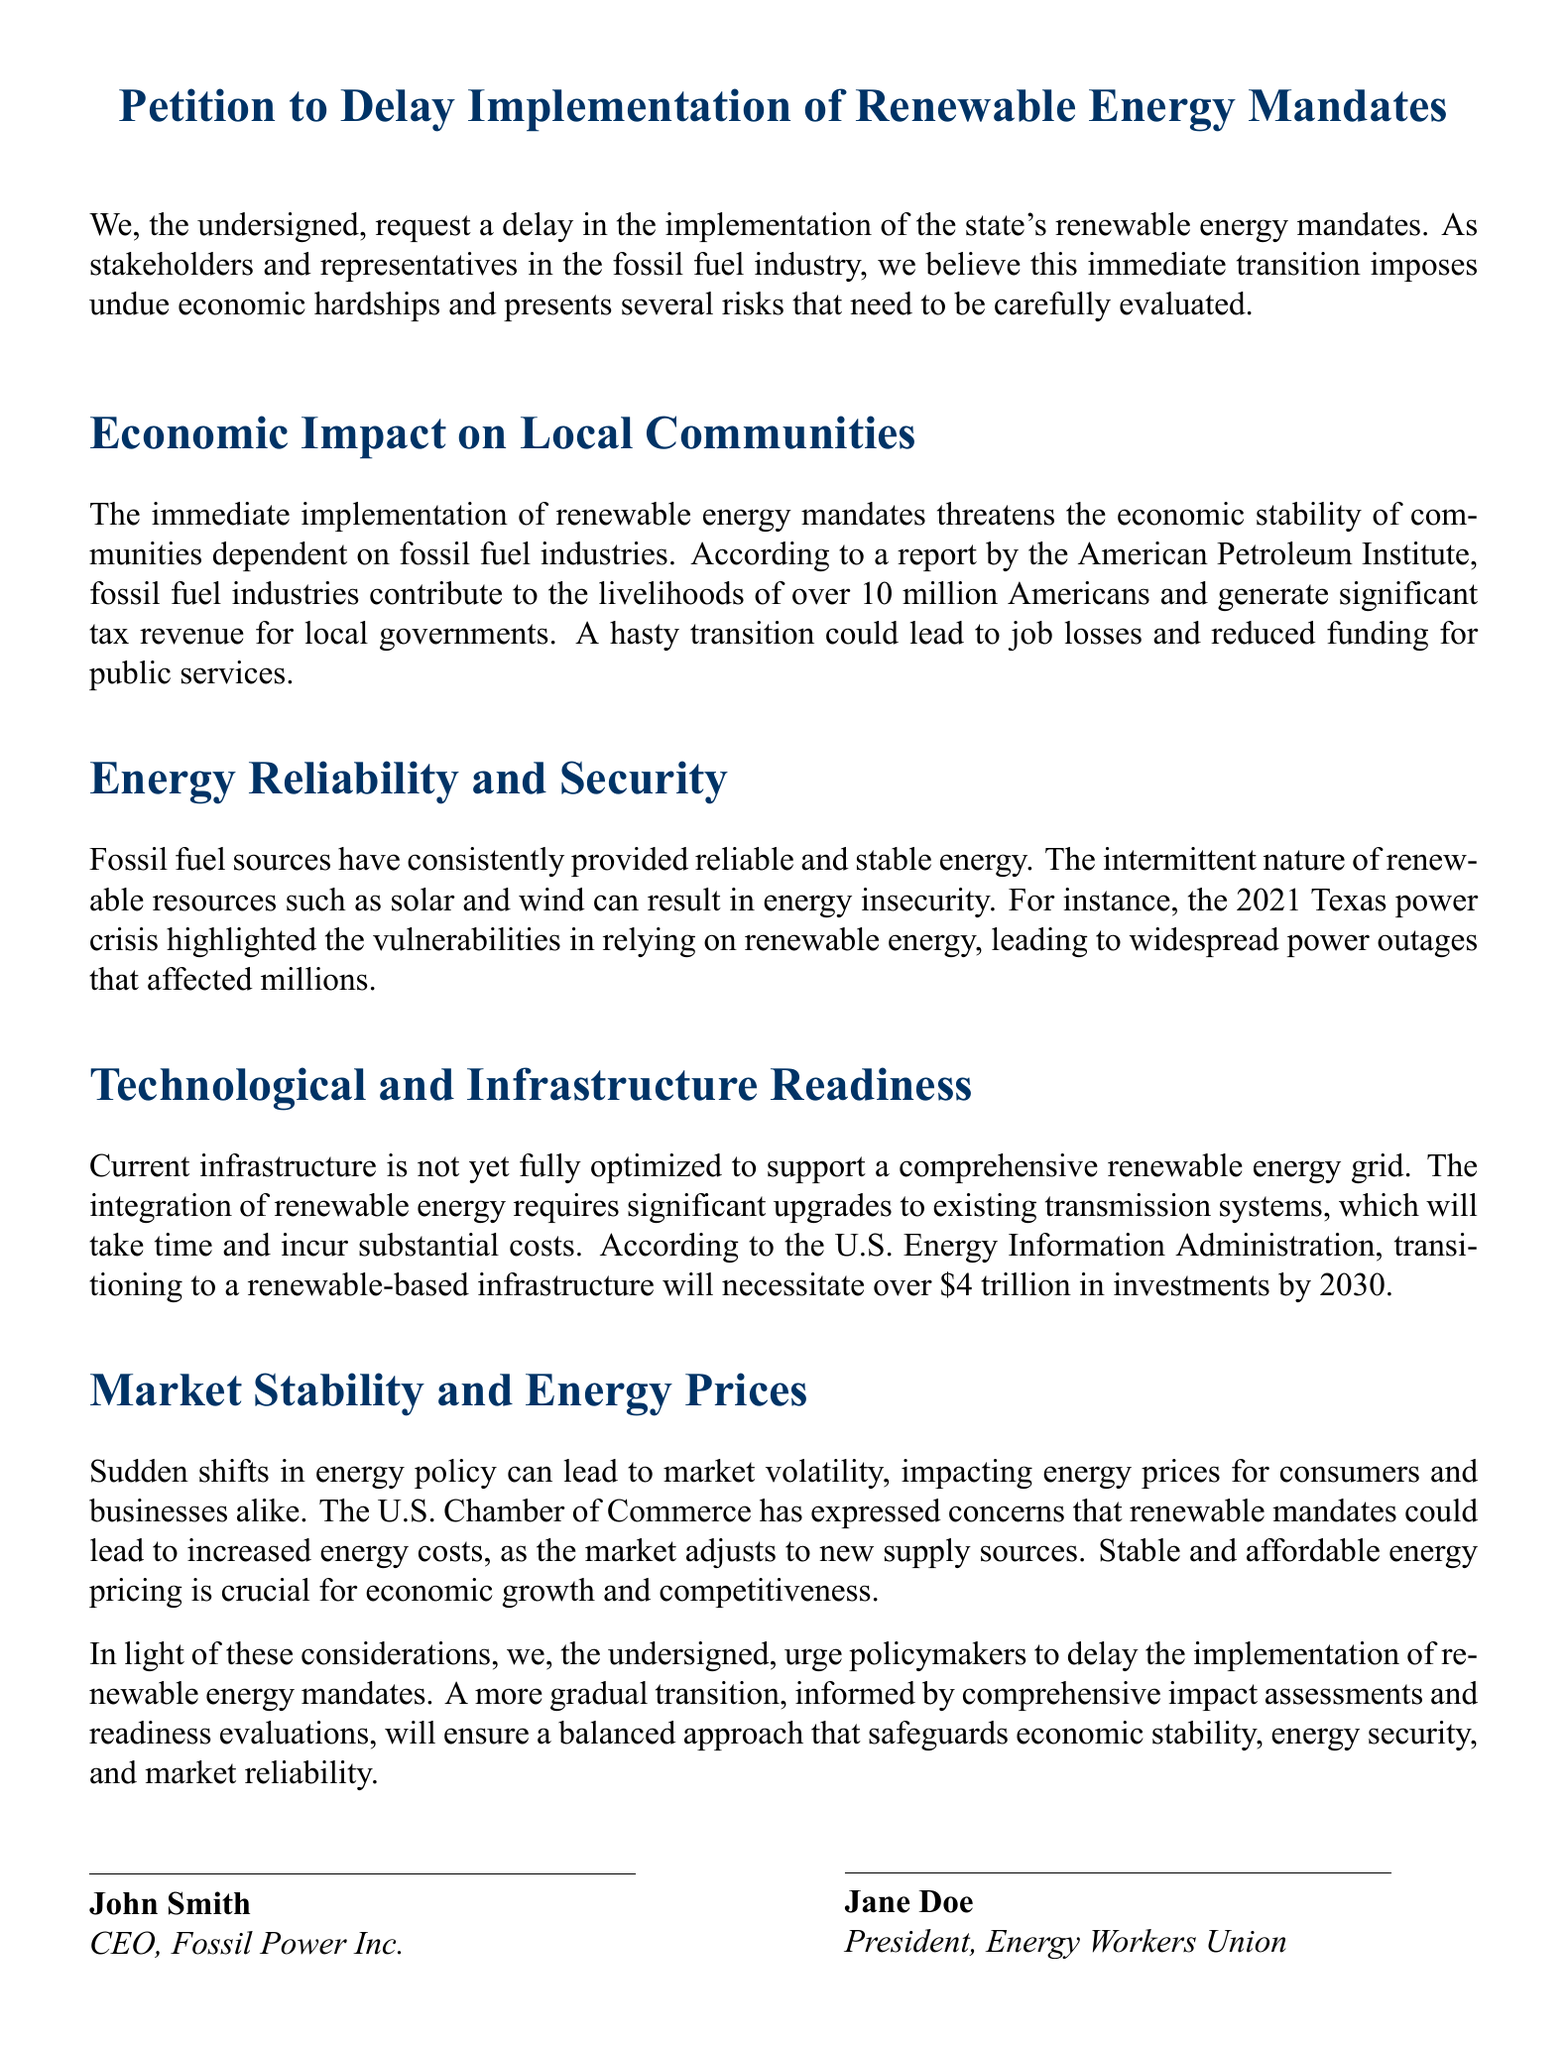What is the title of the petition? The title of the petition is clearly stated at the top of the document.
Answer: Petition to Delay Implementation of Renewable Energy Mandates How many signatures are displayed? The document shows three signatures from individuals representing fossil fuel stakeholders.
Answer: Three What does the American Petroleum Institute report suggest? The report highlights the impact of fossil fuel industries on jobs and tax revenue, which is mentioned in the economic impact section.
Answer: Significant tax revenue for local governments What event is referenced as an example of energy insecurity? The document refers to a specific event to illustrate vulnerabilities in relying on renewable energy.
Answer: 2021 Texas power crisis How much investment is required for transitioning to a renewable-based infrastructure by 2030? The document provides a specific monetary figure for the required investments mentioned in the technological readiness section.
Answer: Over $4 trillion What is a potential consequence of sudden shifts in energy policy? The document discusses market volatility as a risk associated with rapid changes in energy policy.
Answer: Market volatility 